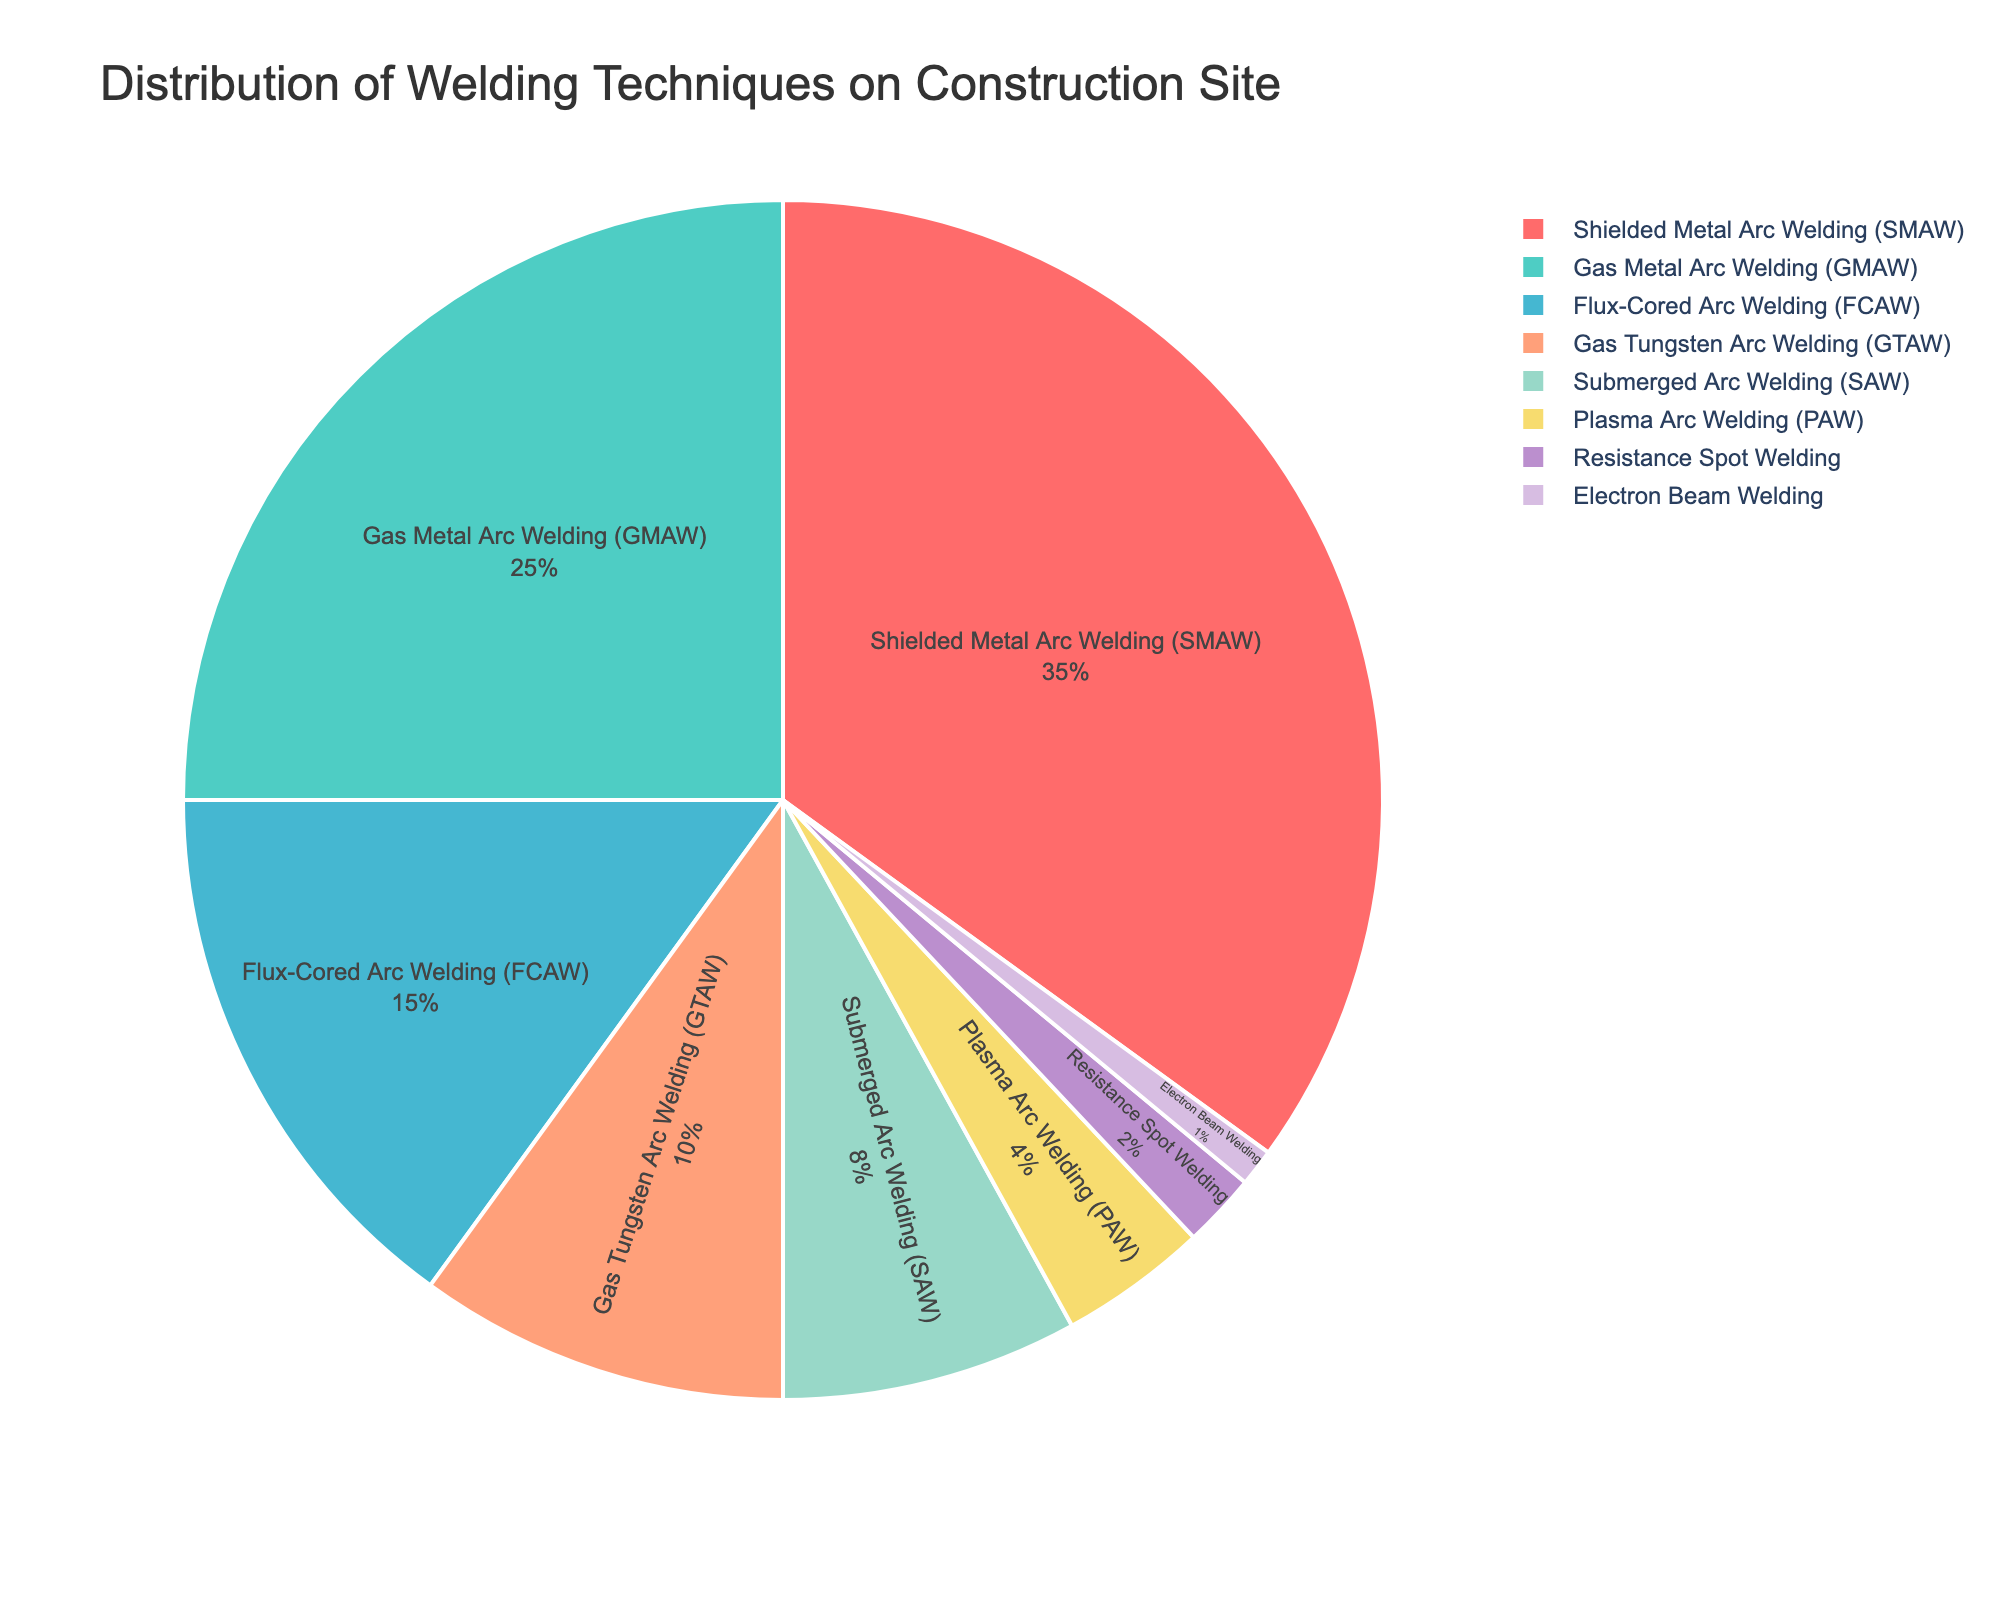Which welding technique is the most commonly used on the construction site? The pie chart shows the distribution, with Shielded Metal Arc Welding (SMAW) occupying the largest segment of the chart.
Answer: Shielded Metal Arc Welding (SMAW) What's the combined percentage of the two least used welding techniques? Find the two smallest percentages in the pie chart, which are for Electron Beam Welding (1%) and Resistance Spot Welding (2%). Add these together: 1% + 2% = 3%.
Answer: 3% How does the usage of Shielded Metal Arc Welding (SMAW) compare to Gas Metal Arc Welding (GMAW)? Shielded Metal Arc Welding (SMAW) has a segment labeled as 35% while Gas Metal Arc Welding (GMAW) has 25%. SMAW is greater than GMAW by 10%.
Answer: SMAW is 10% more than GMAW What is the visual color of the segment representing Flux-Cored Arc Welding (FCAW)? The segment labeled Flux-Cored Arc Welding (FCAW) is in yellow.
Answer: Yellow Which three welding techniques together make up more than 50% of the distribution? Identify the largest segments until their sum exceeds 50%. SMAW (35%), GMAW (25%), and FCAW (15%) together sum up to 75%.
Answer: SMAW, GMAW, FCAW If you combine the percentages of Gas Tungsten Arc Welding (GTAW) and Submerged Arc Welding (SAW), does it surpass the percentage of Flux-Cored Arc Welding (FCAW)? Add the percentages of GTAW (10%) and SAW (8%) to get 18%, which is greater than FCAW's 15%.
Answer: Yes Which technique has the smallest representation, and what is its percentage? The pie chart shows Electron Beam Welding has the smallest segment with 1%.
Answer: Electron Beam Welding, 1% What's the difference in percentage points between the most used and the least used welding techniques? Subtract the percentage of the least used technique (1% for Electron Beam Welding) from the most used technique (35% for SMAW): 35% - 1% = 34%.
Answer: 34% How does the combined percentage of SAW and PAW compare to the percentage of SMAW? Add the percentages of SAW (8%) and PAW (4%) to get 12%. Compare this to SMAW's 35%. 12% is less than 35%.
Answer: SAW and PAW combined are less than SMAW Which technique occupies the second largest segment, and what percentage of the distribution does it represent? The second largest percentage segment in the pie chart is Gas Metal Arc Welding (GMAW) with 25%.
Answer: Gas Metal Arc Welding (GMAW), 25% 